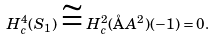<formula> <loc_0><loc_0><loc_500><loc_500>H ^ { 4 } _ { c } ( S _ { 1 } ) \cong H ^ { 2 } _ { c } ( \AA A ^ { 2 } ) ( - 1 ) = 0 .</formula> 